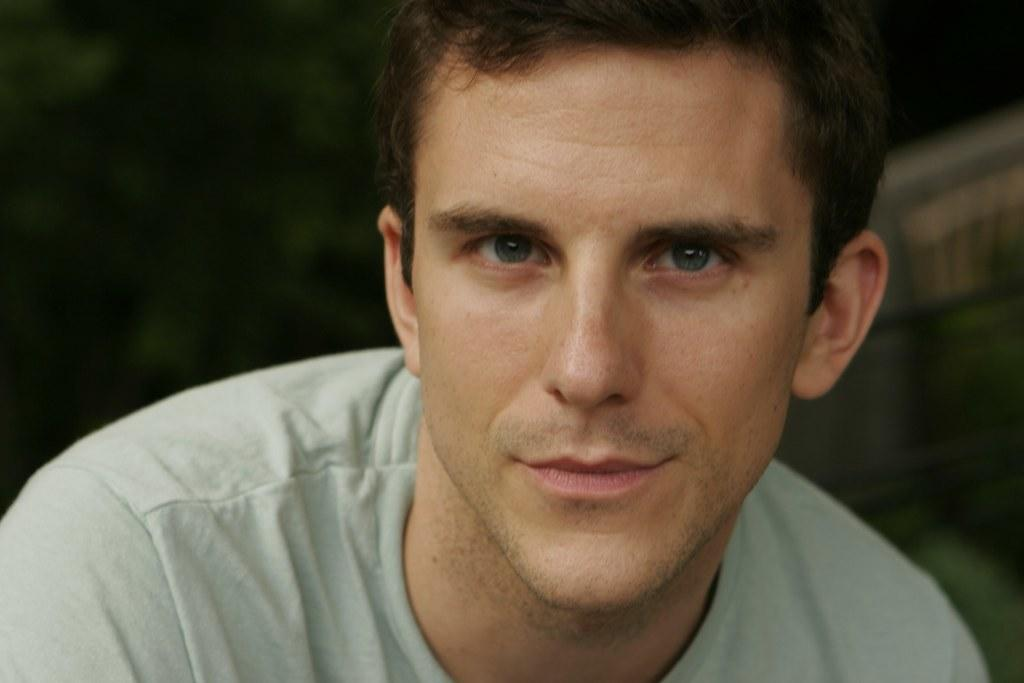Who is the main subject in the image? There is a man in the center of the image. What type of leather can be seen on the ship in the image? There is no ship or leather present in the image; it only features a man in the center. 